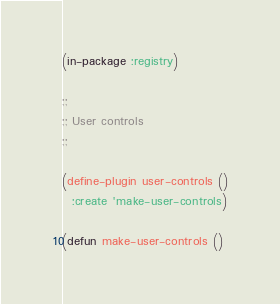Convert code to text. <code><loc_0><loc_0><loc_500><loc_500><_Lisp_>(in-package :registry)

;;
;; User controls
;;

(define-plugin user-controls ()
  :create 'make-user-controls)

(defun make-user-controls ()</code> 